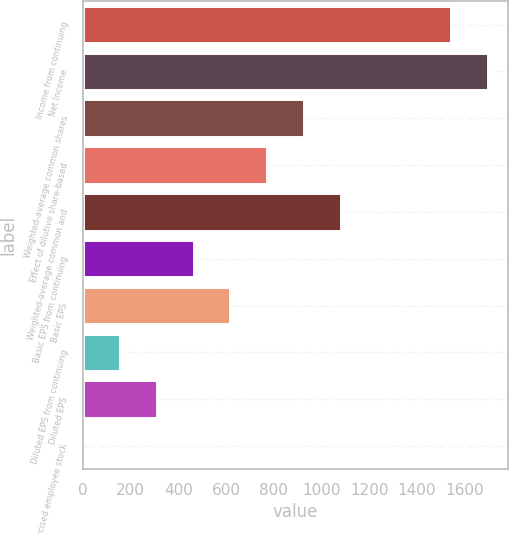Convert chart. <chart><loc_0><loc_0><loc_500><loc_500><bar_chart><fcel>Income from continuing<fcel>Net Income<fcel>Weighted-average common shares<fcel>Effect of dilutive share-based<fcel>Weighted-average common and<fcel>Basic EPS from continuing<fcel>Basic EPS<fcel>Diluted EPS from continuing<fcel>Diluted EPS<fcel>Unexercised employee stock<nl><fcel>1542<fcel>1696<fcel>926<fcel>772<fcel>1080<fcel>464<fcel>618<fcel>156<fcel>310<fcel>2<nl></chart> 